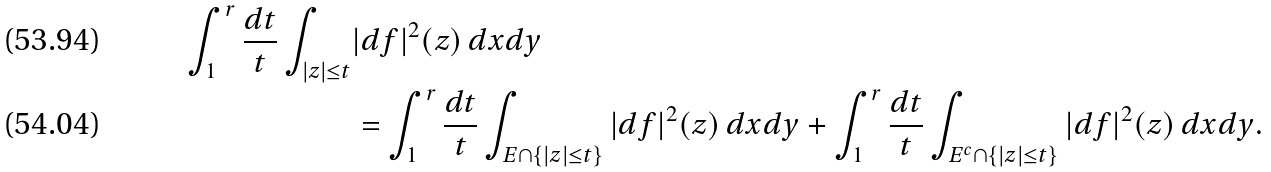Convert formula to latex. <formula><loc_0><loc_0><loc_500><loc_500>\int _ { 1 } ^ { r } \frac { d t } { t } \int _ { | z | \leq t } & | d f | ^ { 2 } ( z ) \, d x d y \\ & = \int _ { 1 } ^ { r } \frac { d t } { t } \int _ { E \cap \{ | z | \leq t \} } | d f | ^ { 2 } ( z ) \, d x d y + \int _ { 1 } ^ { r } \frac { d t } { t } \int _ { E ^ { c } \cap \{ | z | \leq t \} } | d f | ^ { 2 } ( z ) \, d x d y .</formula> 